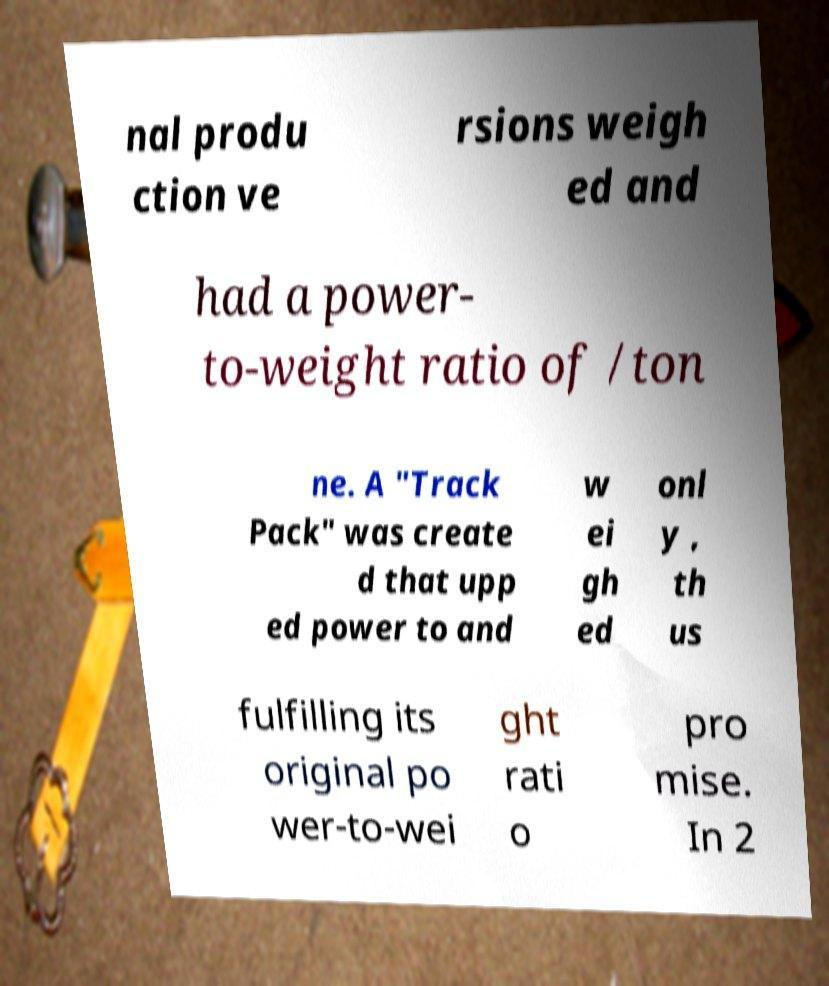Can you accurately transcribe the text from the provided image for me? nal produ ction ve rsions weigh ed and had a power- to-weight ratio of /ton ne. A "Track Pack" was create d that upp ed power to and w ei gh ed onl y , th us fulfilling its original po wer-to-wei ght rati o pro mise. In 2 